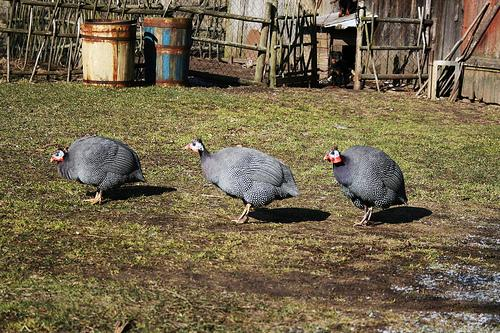What is the brown areas on the barrels?

Choices:
A) animal droppings
B) rust
C) syrup stains
D) paint rust 